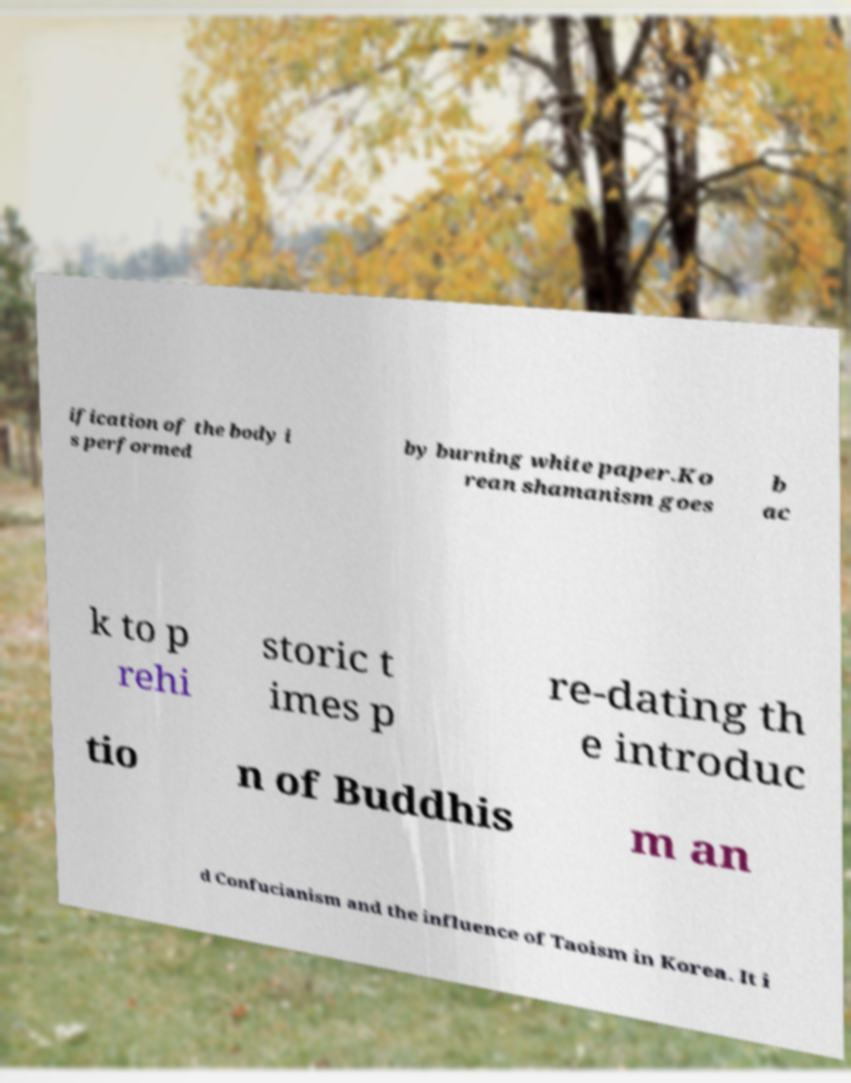Can you accurately transcribe the text from the provided image for me? ification of the body i s performed by burning white paper.Ko rean shamanism goes b ac k to p rehi storic t imes p re-dating th e introduc tio n of Buddhis m an d Confucianism and the influence of Taoism in Korea. It i 